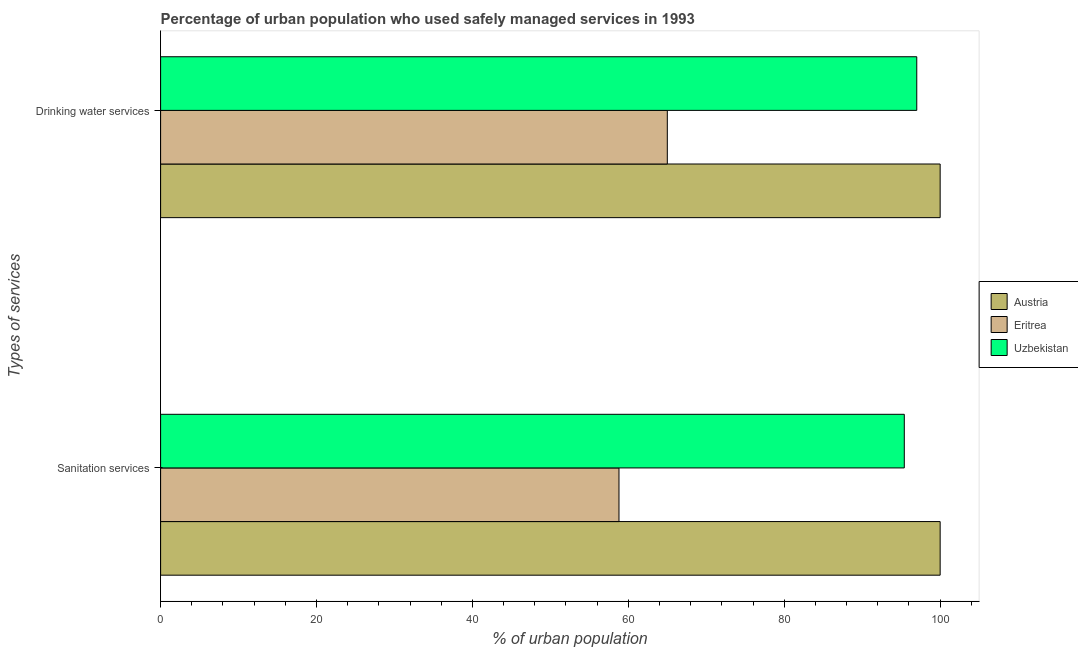Are the number of bars per tick equal to the number of legend labels?
Make the answer very short. Yes. Are the number of bars on each tick of the Y-axis equal?
Your answer should be very brief. Yes. How many bars are there on the 2nd tick from the top?
Provide a short and direct response. 3. How many bars are there on the 2nd tick from the bottom?
Give a very brief answer. 3. What is the label of the 2nd group of bars from the top?
Give a very brief answer. Sanitation services. What is the percentage of urban population who used sanitation services in Eritrea?
Provide a succinct answer. 58.8. Across all countries, what is the maximum percentage of urban population who used drinking water services?
Provide a short and direct response. 100. Across all countries, what is the minimum percentage of urban population who used drinking water services?
Your response must be concise. 65. In which country was the percentage of urban population who used drinking water services maximum?
Offer a terse response. Austria. In which country was the percentage of urban population who used drinking water services minimum?
Offer a terse response. Eritrea. What is the total percentage of urban population who used sanitation services in the graph?
Your answer should be compact. 254.2. What is the difference between the percentage of urban population who used sanitation services in Eritrea and that in Uzbekistan?
Your answer should be very brief. -36.6. What is the difference between the percentage of urban population who used sanitation services in Eritrea and the percentage of urban population who used drinking water services in Uzbekistan?
Give a very brief answer. -38.2. What is the average percentage of urban population who used sanitation services per country?
Your response must be concise. 84.73. What is the ratio of the percentage of urban population who used sanitation services in Austria to that in Eritrea?
Offer a very short reply. 1.7. What does the 2nd bar from the top in Drinking water services represents?
Give a very brief answer. Eritrea. What does the 1st bar from the bottom in Sanitation services represents?
Give a very brief answer. Austria. Are all the bars in the graph horizontal?
Make the answer very short. Yes. How many countries are there in the graph?
Your answer should be very brief. 3. Are the values on the major ticks of X-axis written in scientific E-notation?
Make the answer very short. No. How many legend labels are there?
Your answer should be compact. 3. What is the title of the graph?
Ensure brevity in your answer.  Percentage of urban population who used safely managed services in 1993. Does "World" appear as one of the legend labels in the graph?
Ensure brevity in your answer.  No. What is the label or title of the X-axis?
Provide a succinct answer. % of urban population. What is the label or title of the Y-axis?
Offer a very short reply. Types of services. What is the % of urban population of Austria in Sanitation services?
Make the answer very short. 100. What is the % of urban population of Eritrea in Sanitation services?
Provide a succinct answer. 58.8. What is the % of urban population of Uzbekistan in Sanitation services?
Offer a terse response. 95.4. What is the % of urban population of Eritrea in Drinking water services?
Your answer should be very brief. 65. What is the % of urban population in Uzbekistan in Drinking water services?
Your answer should be compact. 97. Across all Types of services, what is the maximum % of urban population in Eritrea?
Your answer should be compact. 65. Across all Types of services, what is the maximum % of urban population of Uzbekistan?
Provide a succinct answer. 97. Across all Types of services, what is the minimum % of urban population in Austria?
Offer a terse response. 100. Across all Types of services, what is the minimum % of urban population of Eritrea?
Your response must be concise. 58.8. Across all Types of services, what is the minimum % of urban population of Uzbekistan?
Your answer should be compact. 95.4. What is the total % of urban population in Eritrea in the graph?
Keep it short and to the point. 123.8. What is the total % of urban population in Uzbekistan in the graph?
Your answer should be compact. 192.4. What is the difference between the % of urban population of Austria in Sanitation services and that in Drinking water services?
Give a very brief answer. 0. What is the difference between the % of urban population of Uzbekistan in Sanitation services and that in Drinking water services?
Your response must be concise. -1.6. What is the difference between the % of urban population in Eritrea in Sanitation services and the % of urban population in Uzbekistan in Drinking water services?
Your answer should be compact. -38.2. What is the average % of urban population of Eritrea per Types of services?
Offer a very short reply. 61.9. What is the average % of urban population of Uzbekistan per Types of services?
Ensure brevity in your answer.  96.2. What is the difference between the % of urban population in Austria and % of urban population in Eritrea in Sanitation services?
Give a very brief answer. 41.2. What is the difference between the % of urban population in Austria and % of urban population in Uzbekistan in Sanitation services?
Keep it short and to the point. 4.6. What is the difference between the % of urban population in Eritrea and % of urban population in Uzbekistan in Sanitation services?
Ensure brevity in your answer.  -36.6. What is the difference between the % of urban population of Austria and % of urban population of Eritrea in Drinking water services?
Offer a very short reply. 35. What is the difference between the % of urban population of Eritrea and % of urban population of Uzbekistan in Drinking water services?
Your answer should be very brief. -32. What is the ratio of the % of urban population of Eritrea in Sanitation services to that in Drinking water services?
Ensure brevity in your answer.  0.9. What is the ratio of the % of urban population in Uzbekistan in Sanitation services to that in Drinking water services?
Make the answer very short. 0.98. What is the difference between the highest and the second highest % of urban population of Eritrea?
Offer a terse response. 6.2. What is the difference between the highest and the second highest % of urban population of Uzbekistan?
Make the answer very short. 1.6. What is the difference between the highest and the lowest % of urban population in Uzbekistan?
Offer a terse response. 1.6. 